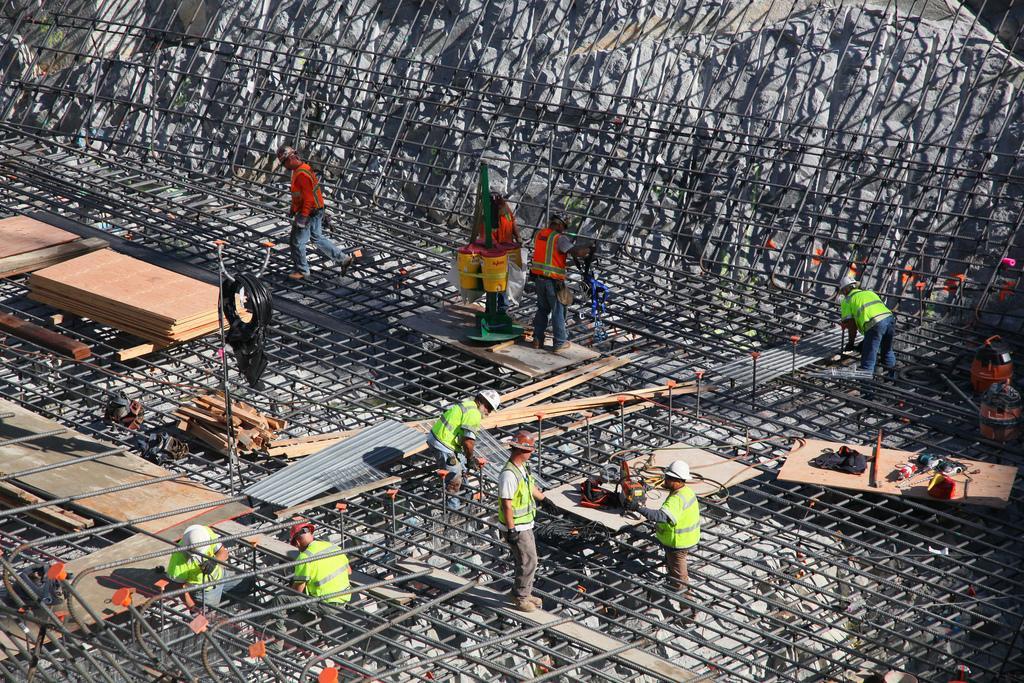Can you describe this image briefly? In this picture there are people in the center of the image, they are working, there are wooden pieces on the left side of the image and there is net around the area of the image. 